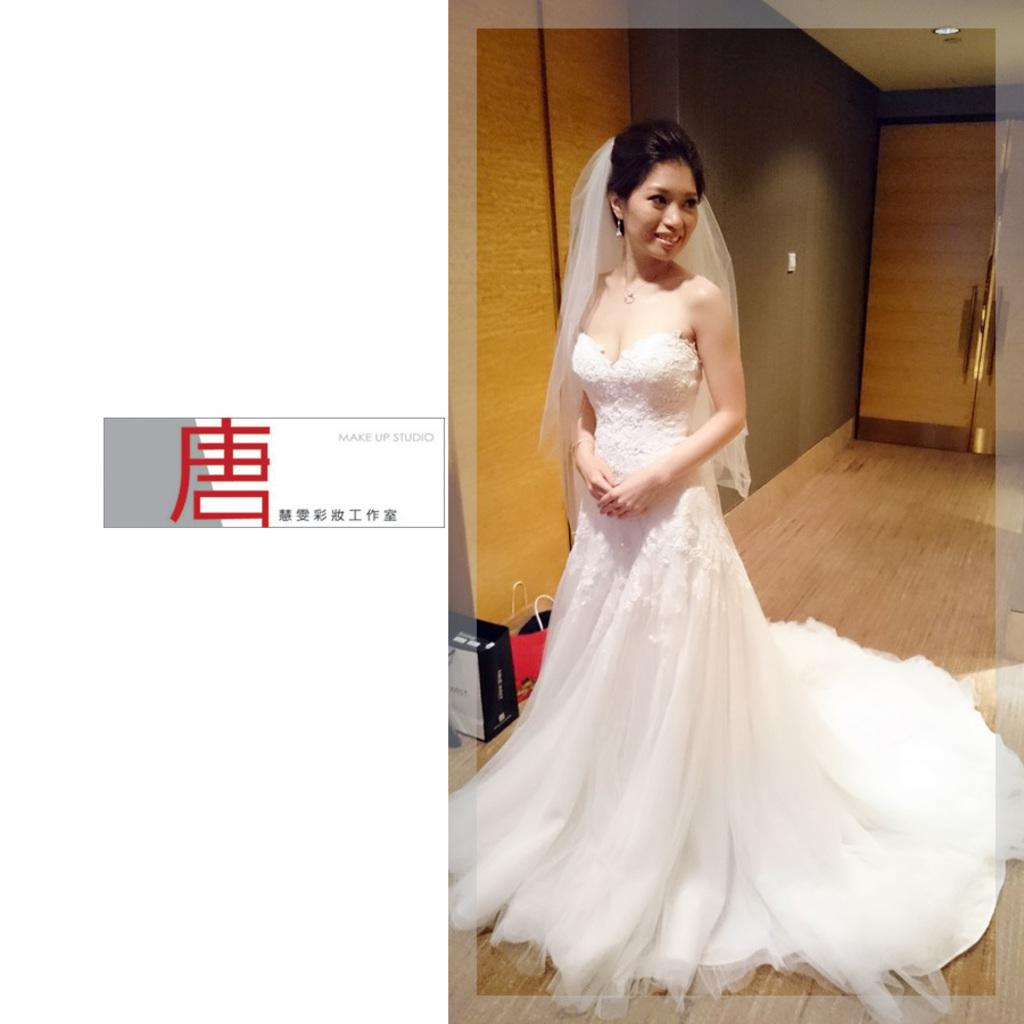Who is the main subject in the image? There is a woman in the image. What is the woman wearing? The woman is wearing a white bridal dress. What type of floor is visible in the image? The woman is standing on a wooden floor. What is located beside the woman in the image? There is a wall beside the woman. What type of thrill ride is the woman riding in the image? There is no thrill ride present in the image; the woman is standing on a wooden floor beside a wall. Can you tell me about the carriage that the woman is driving in the image? There is no carriage present in the image; the woman is wearing a white bridal dress and standing on a wooden floor beside a wall. 